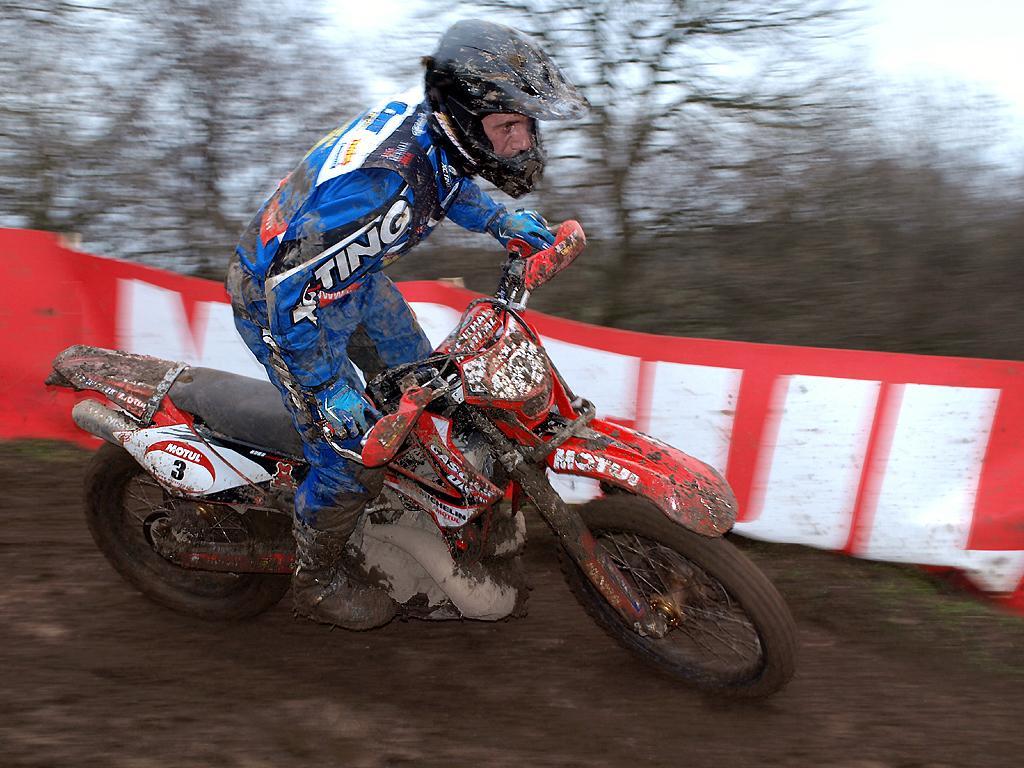Could you give a brief overview of what you see in this image? In the image there is a man with blue dress is standing on the bike and holding the bike. Behind him there is a red and white color poster. In the background there are trees. There is mud on man and bike. 